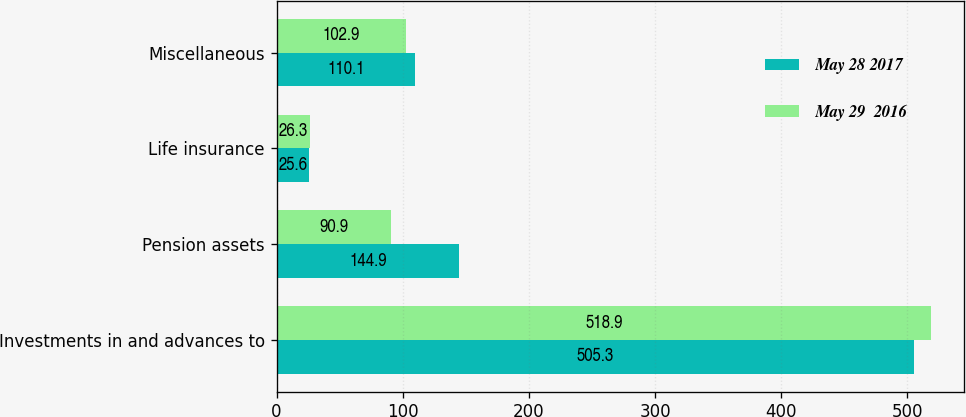Convert chart. <chart><loc_0><loc_0><loc_500><loc_500><stacked_bar_chart><ecel><fcel>Investments in and advances to<fcel>Pension assets<fcel>Life insurance<fcel>Miscellaneous<nl><fcel>May 28 2017<fcel>505.3<fcel>144.9<fcel>25.6<fcel>110.1<nl><fcel>May 29  2016<fcel>518.9<fcel>90.9<fcel>26.3<fcel>102.9<nl></chart> 